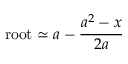<formula> <loc_0><loc_0><loc_500><loc_500>r o o t \simeq a - { \frac { a ^ { 2 } - x } { 2 a } } \,</formula> 